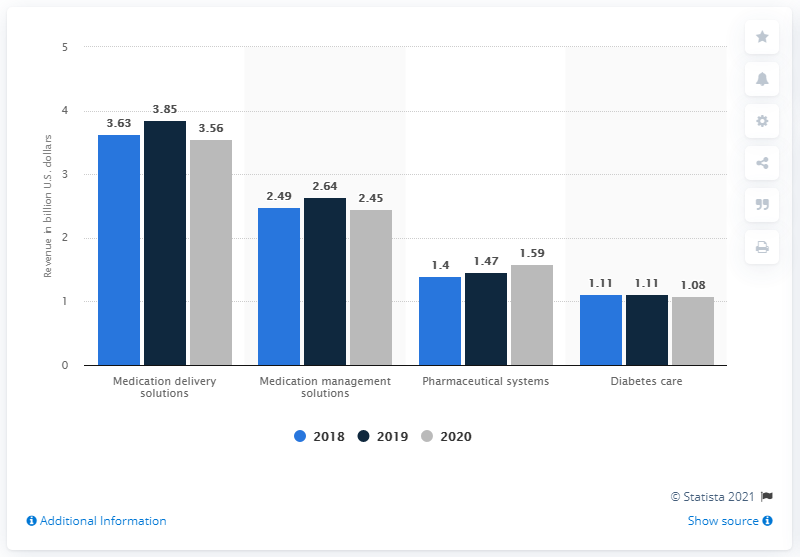Outline some significant characteristics in this image. In the United States in 2020, the medical delivery solutions generated approximately 3.56 billion dollars. 